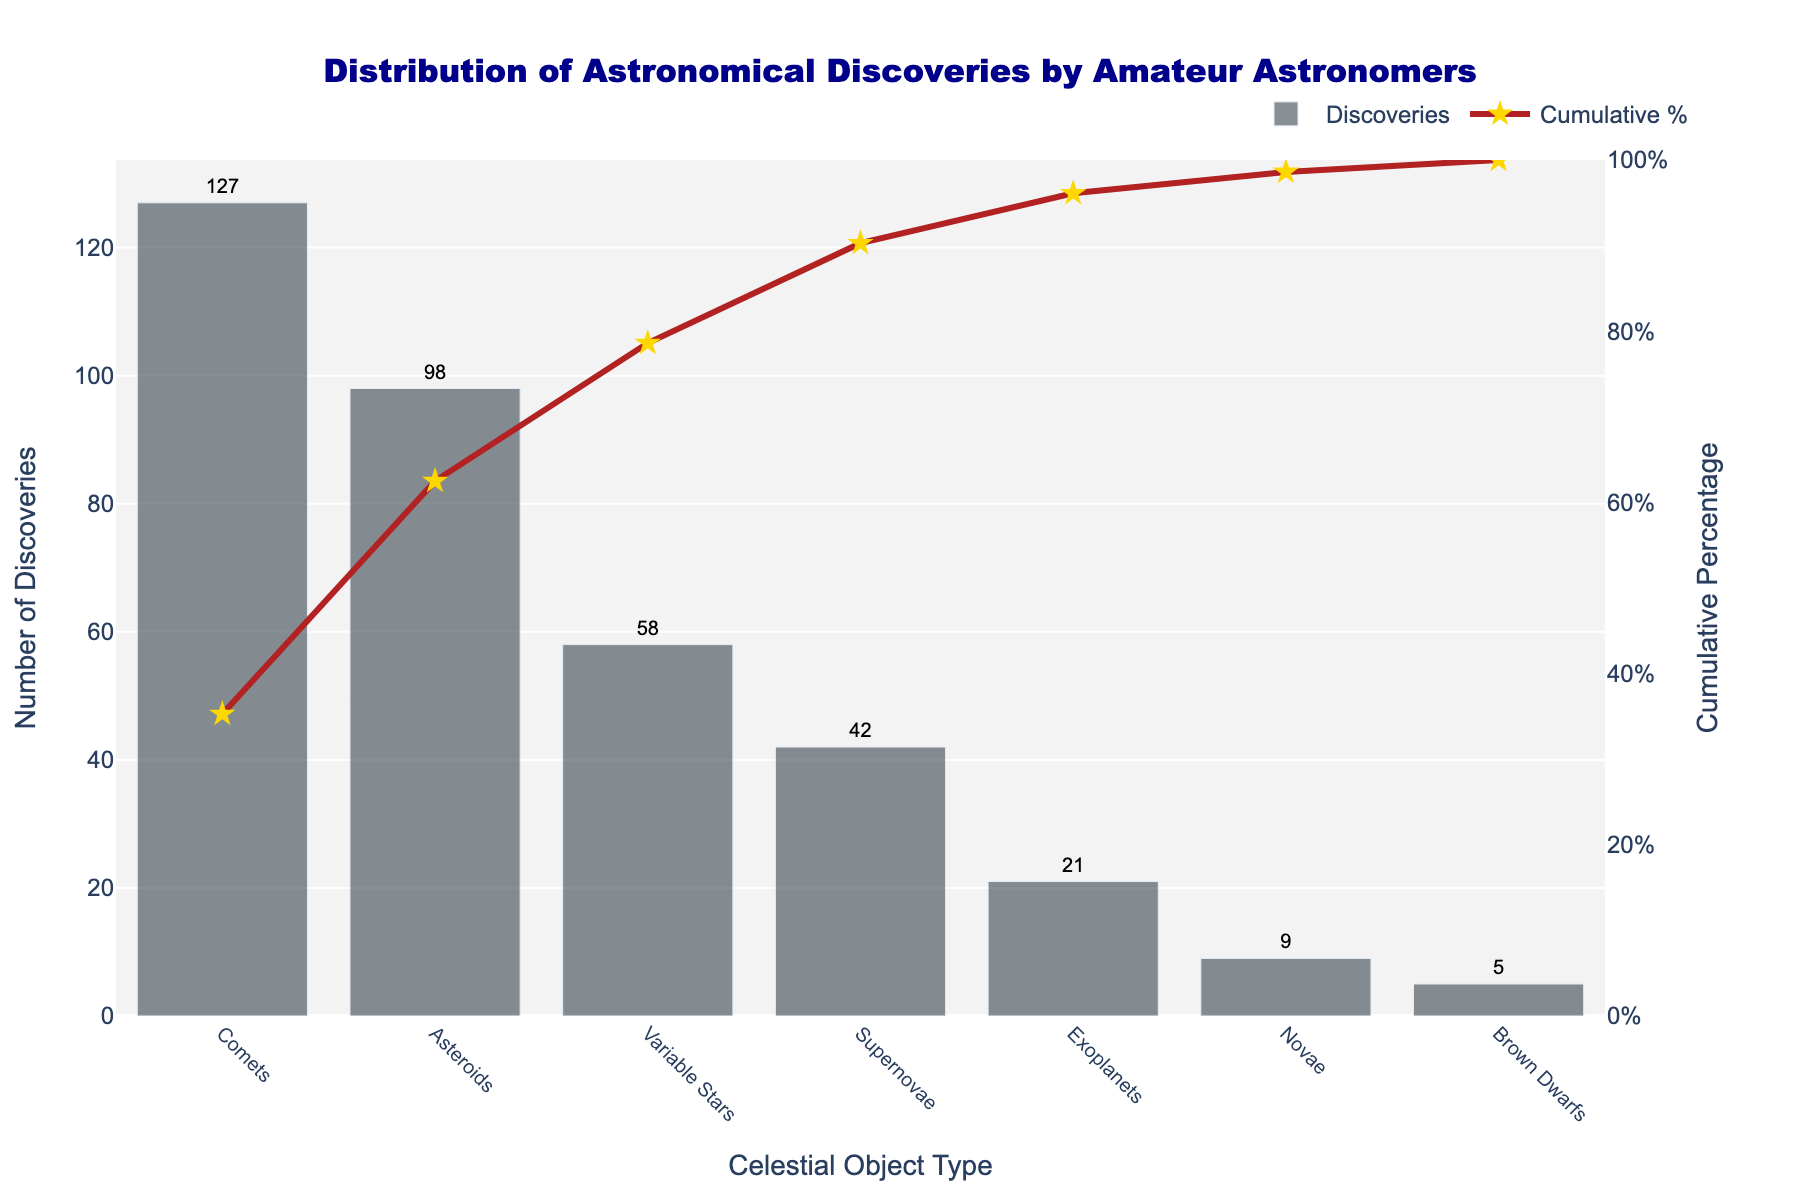What is the celestial object type with the most discoveries by amateur astronomers? The bar chart shows the number of discoveries for each celestial object type. The bar for "Comets" is the highest, indicating that comets have the most discoveries.
Answer: Comets What is the cumulative percentage of discoveries for comets and asteroids combined? The cumulative percentage for comets is 35.28%. Adding the percentage for asteroids, which is 62.50%, we get 62.50%.
Answer: 62.50% How many more discoveries are there for comets compared to brown dwarfs? The number of discoveries for comets is 127, and for brown dwarfs, it is 5. Subtracting the number of brown dwarf discoveries from comet discoveries, 127 - 5 = 122.
Answer: 122 Which celestial object type reaches the cumulative percentage of 100%? The line chart for cumulative percentage reaches 100% at "Brown Dwarfs".
Answer: Brown Dwarfs Compare the number of discoveries of supernovae to variable stars. Which type has more discoveries? The bar chart shows that supernovae have 42 discoveries, while variable stars have 58. Thus, variable stars have more discoveries than supernovae.
Answer: Variable Stars What is the cumulative percentage after including discoveries of supernovae? The cumulative percentage after including supernovae is 90.28%.
Answer: 90.28% Which celestial object type has the lowest number of discoveries? The bar chart indicates that "Brown Dwarfs" have the lowest number of discoveries, with 5.
Answer: Brown Dwarfs By how much does the cumulative percentage increase from discovering comets to discovering variable stars? The cumulative percentage for comets is 35.28% and for variable stars, it is 78.61%. The increase is 78.61% - 35.28% = 43.33%.
Answer: 43.33% How many types of celestial objects are represented in the figure? The x-axis of the bar chart lists all the celestial object types, which are 7 in total: Comets, Asteroids, Variable Stars, Supernovae, Exoplanets, Novae, and Brown Dwarfs.
Answer: 7 Which celestial object type contributes the least to the cumulative percentage? The line chart for cumulative percentage shows that the smallest increment toward 100% comes from "Brown Dwarfs".
Answer: Brown Dwarfs 